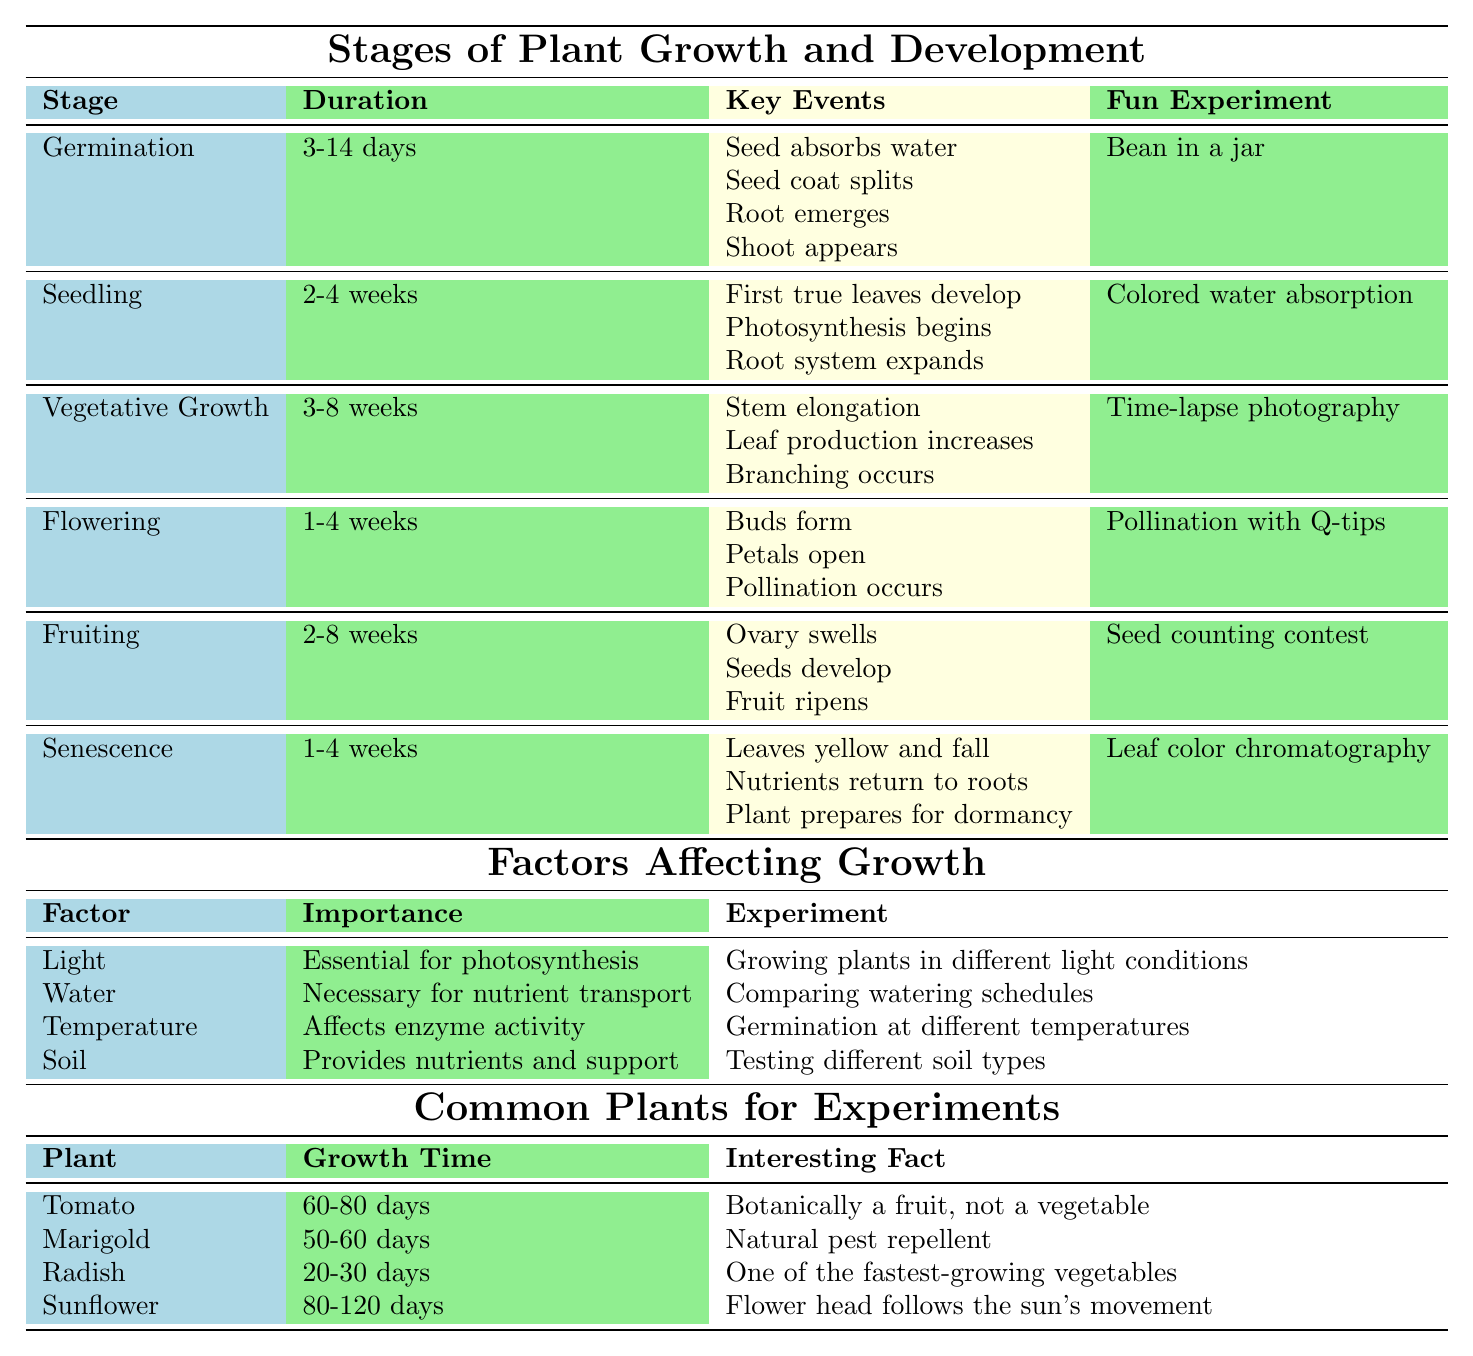What's the duration of the Seedling stage? The table indicates that the duration of the Seedling stage is between 2 and 4 weeks.
Answer: 2-4 weeks What key event happens during the Flowering stage? According to the table, one of the key events during the Flowering stage is that buds form.
Answer: Buds form Which stage has a fun experiment involving a seed counting contest? The table shows that the Fruiting stage has a fun experiment called a seed counting contest.
Answer: Fruiting Is temperature a factor affecting plant growth? Yes, the table lists temperature as one of the factors affecting growth, stating that it affects enzyme activity.
Answer: Yes What is the average growth time of the plants listed in the Common Plants for Experiments section? The growth times are: Tomato (70 days), Marigold (55 days), Radish (25 days), and Sunflower (100 days). The average growth time is calculated as (70 + 55 + 25 + 100) / 4 = 62.5 days.
Answer: 62.5 days Which stage has the shortest duration and what is it? The table shows that Germination has the shortest duration of 3 to 14 days.
Answer: Germination (3-14 days) How many key events are listed for the Vegetative Growth stage? The table presents three key events for the Vegetative Growth stage: stem elongation, leaf production increases, and branching occurs.
Answer: 3 Does the Seedling stage have any events related to photosynthesis? Yes, the table shows that during the Seedling stage, photosynthesis begins.
Answer: Yes What experiment can be done to explore the importance of light in plant growth? The table states that the suggested experiment for exploring the importance of light is growing plants in different light conditions.
Answer: Growing plants in different light conditions Which plant has the longest growth time before it can be harvested? According to the table, the Sunflower has the longest growth time of 80-120 days.
Answer: Sunflower 